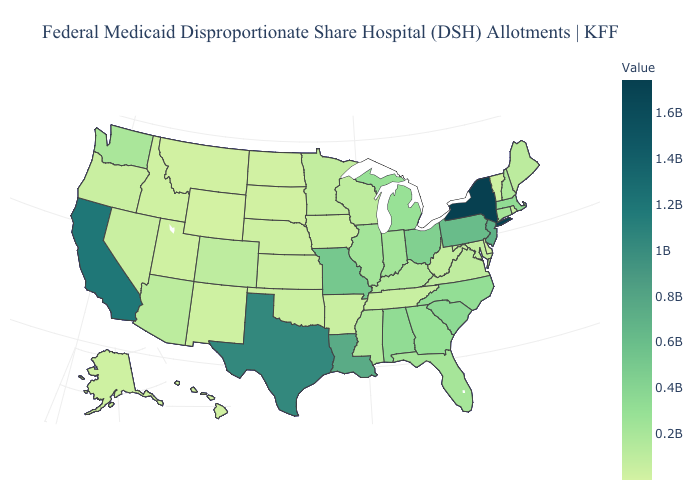Does West Virginia have the highest value in the USA?
Quick response, please. No. Which states have the lowest value in the USA?
Answer briefly. Wyoming. Which states have the lowest value in the South?
Concise answer only. Delaware. Which states have the lowest value in the Northeast?
Quick response, please. Vermont. Does Connecticut have a higher value than Montana?
Keep it brief. Yes. Which states have the lowest value in the MidWest?
Concise answer only. North Dakota. Which states have the lowest value in the MidWest?
Concise answer only. North Dakota. 